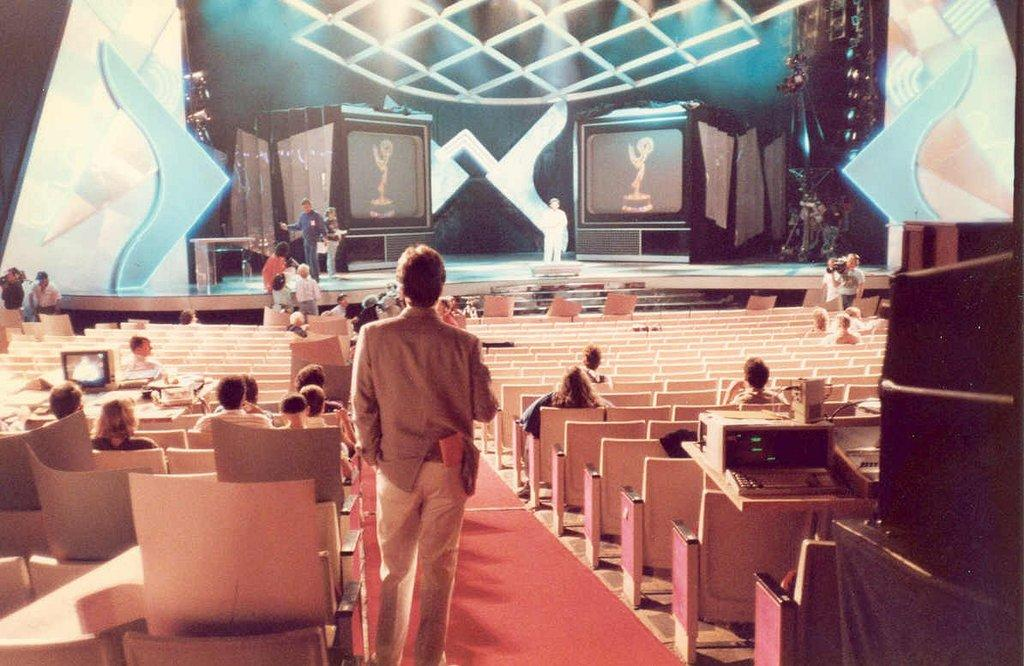What are the people in the image doing? The people in the image are sitting on chairs and standing on the floor. Where are some of the people located in the image? Some people are on stage in the image. What type of flooring is present in the image? There are carpets in the image. What electronic devices can be seen in the image? There are devices in the image. What type of lighting is present in the image? There are lights in the image. What other objects can be seen in the image? There are other objects in the image. What type of pear is hanging from the ceiling in the image? There is no pear present in the image; it is a setting with people, chairs, carpets, devices, and lights. 